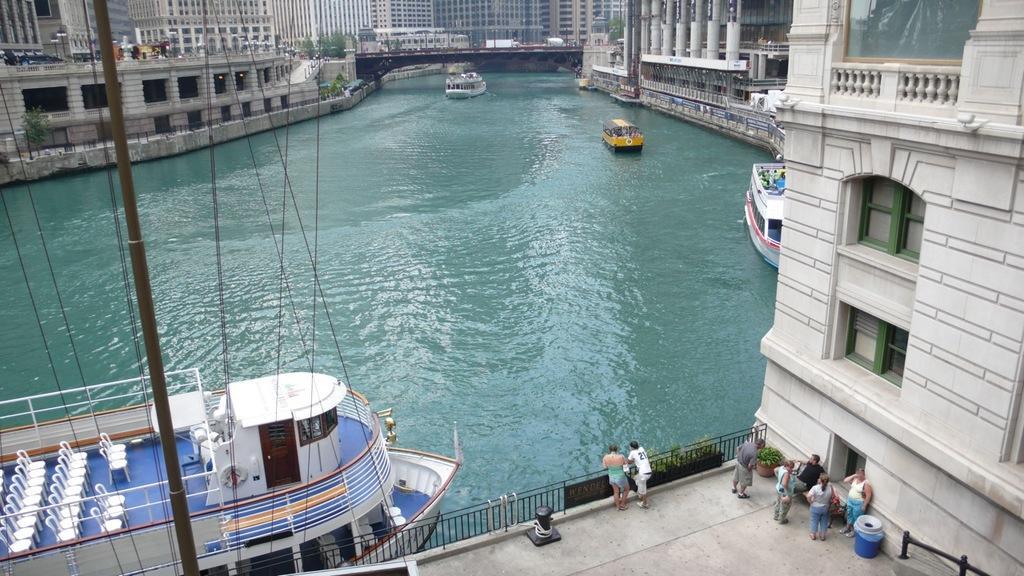Please provide a concise description of this image. In this picture we can see few boats in the water, beside to the boat we can find a fence and few people, in the background we can see few buildings, trees and a bridge over the water. 